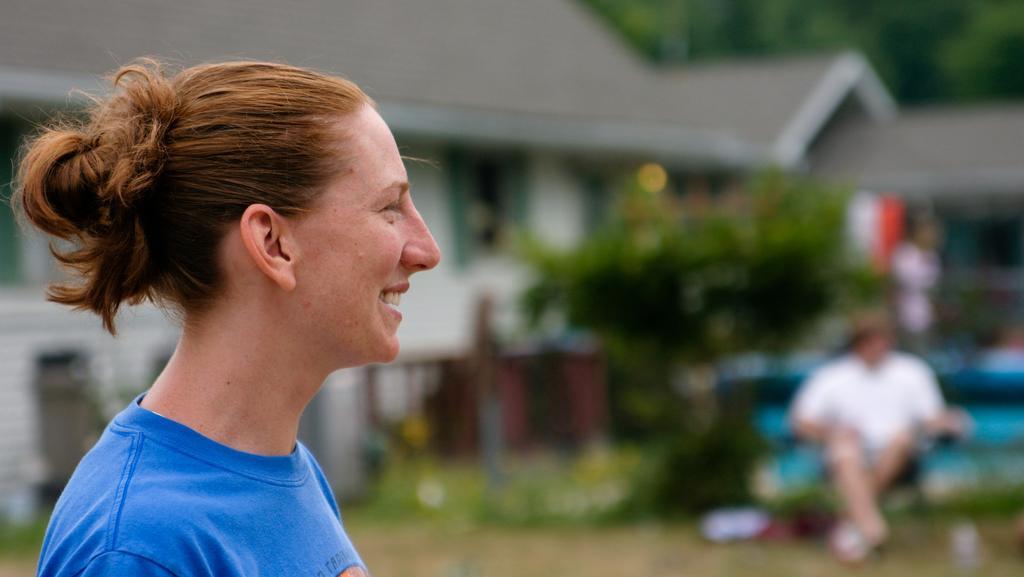Please provide a concise description of this image. In this image in the front there is a person smiling. In the background there are trees, there is a building and there are persons. 